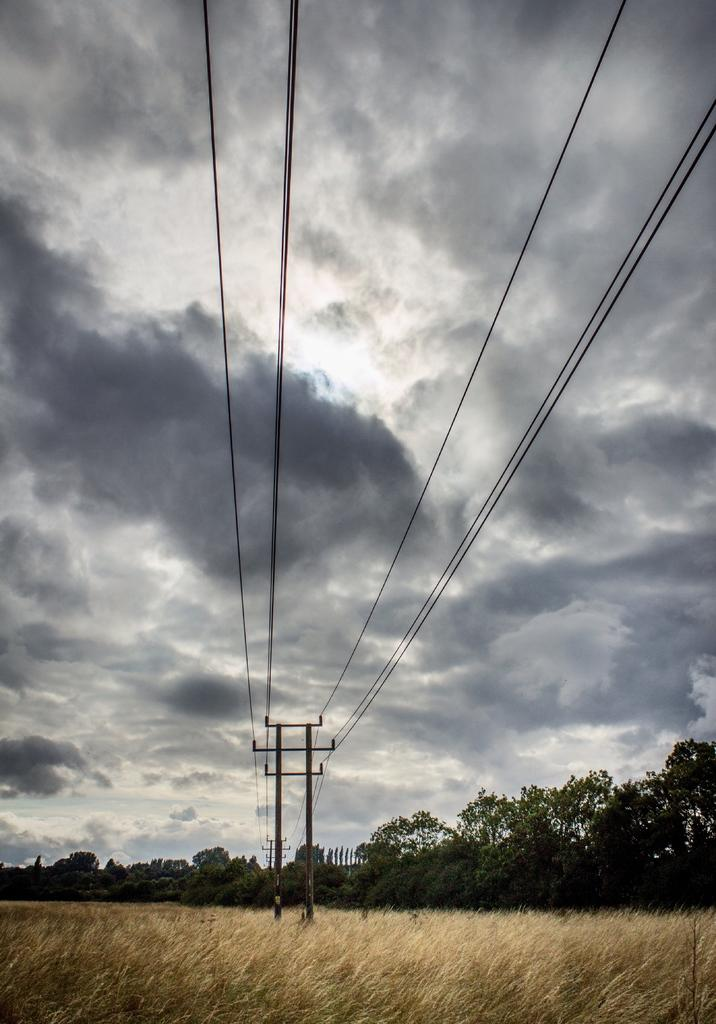What is located in the center of the image? There are two poles and wires in the center of the image. What can be found at the bottom of the image? There are plants at the bottom of the image. What else is present in the center of the image besides the poles and wires? There are trees in the center of the image. What is visible at the top of the image? The sky is visible at the top of the image. What type of organization is depicted in the image? There is no organization depicted in the image; it features poles, wires, trees, plants, and the sky. How many circles can be seen in the image? There are no circles present in the image. 